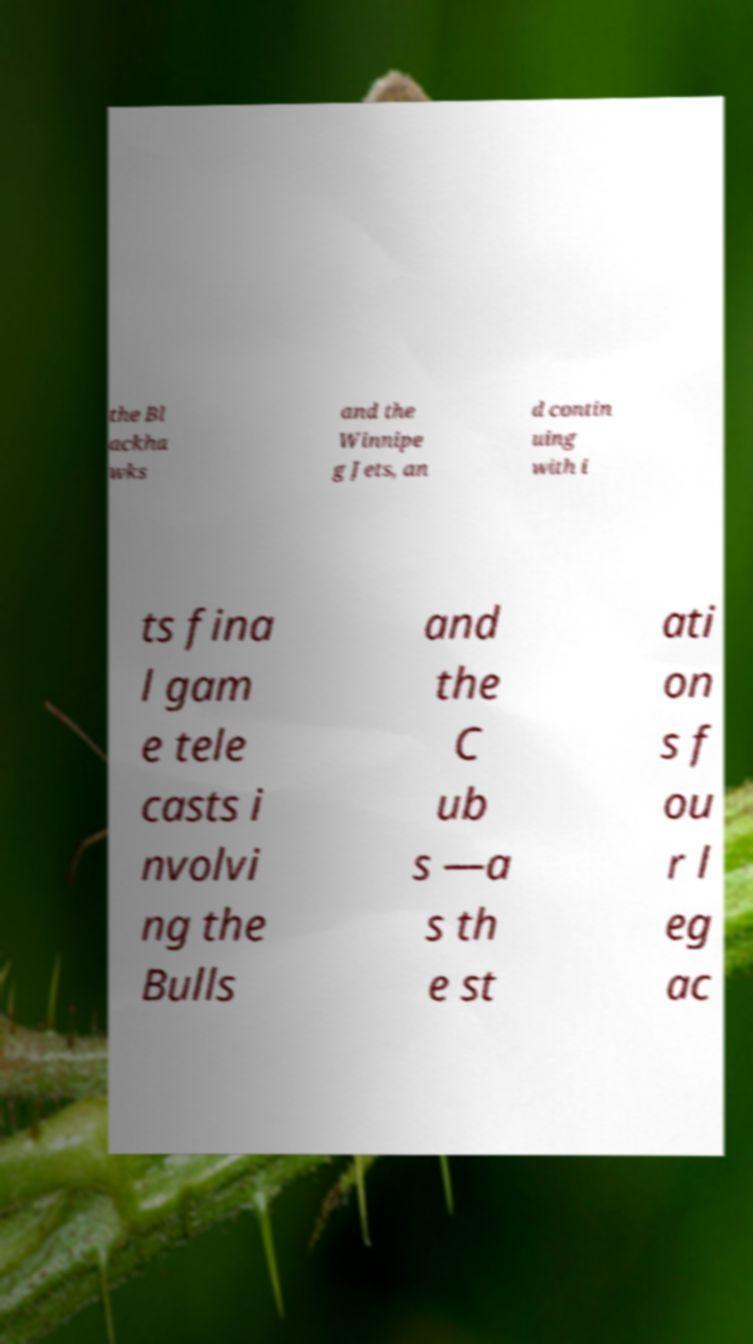Can you read and provide the text displayed in the image?This photo seems to have some interesting text. Can you extract and type it out for me? the Bl ackha wks and the Winnipe g Jets, an d contin uing with i ts fina l gam e tele casts i nvolvi ng the Bulls and the C ub s —a s th e st ati on s f ou r l eg ac 